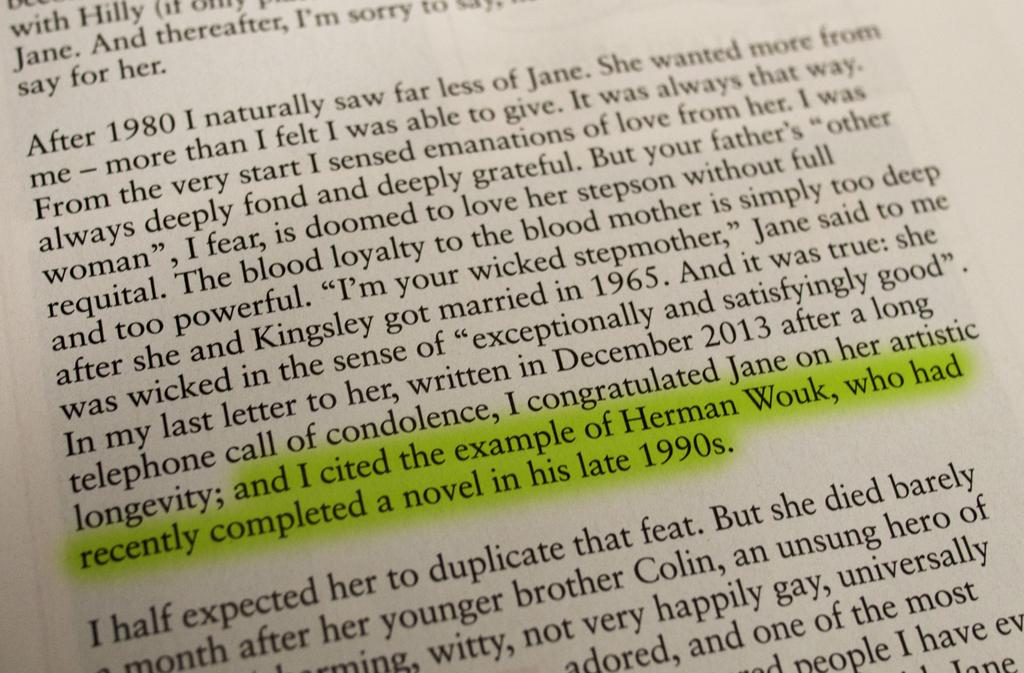Provide a one-sentence caption for the provided image. A highlighted block of text in a book references the author Herman Wouk. 